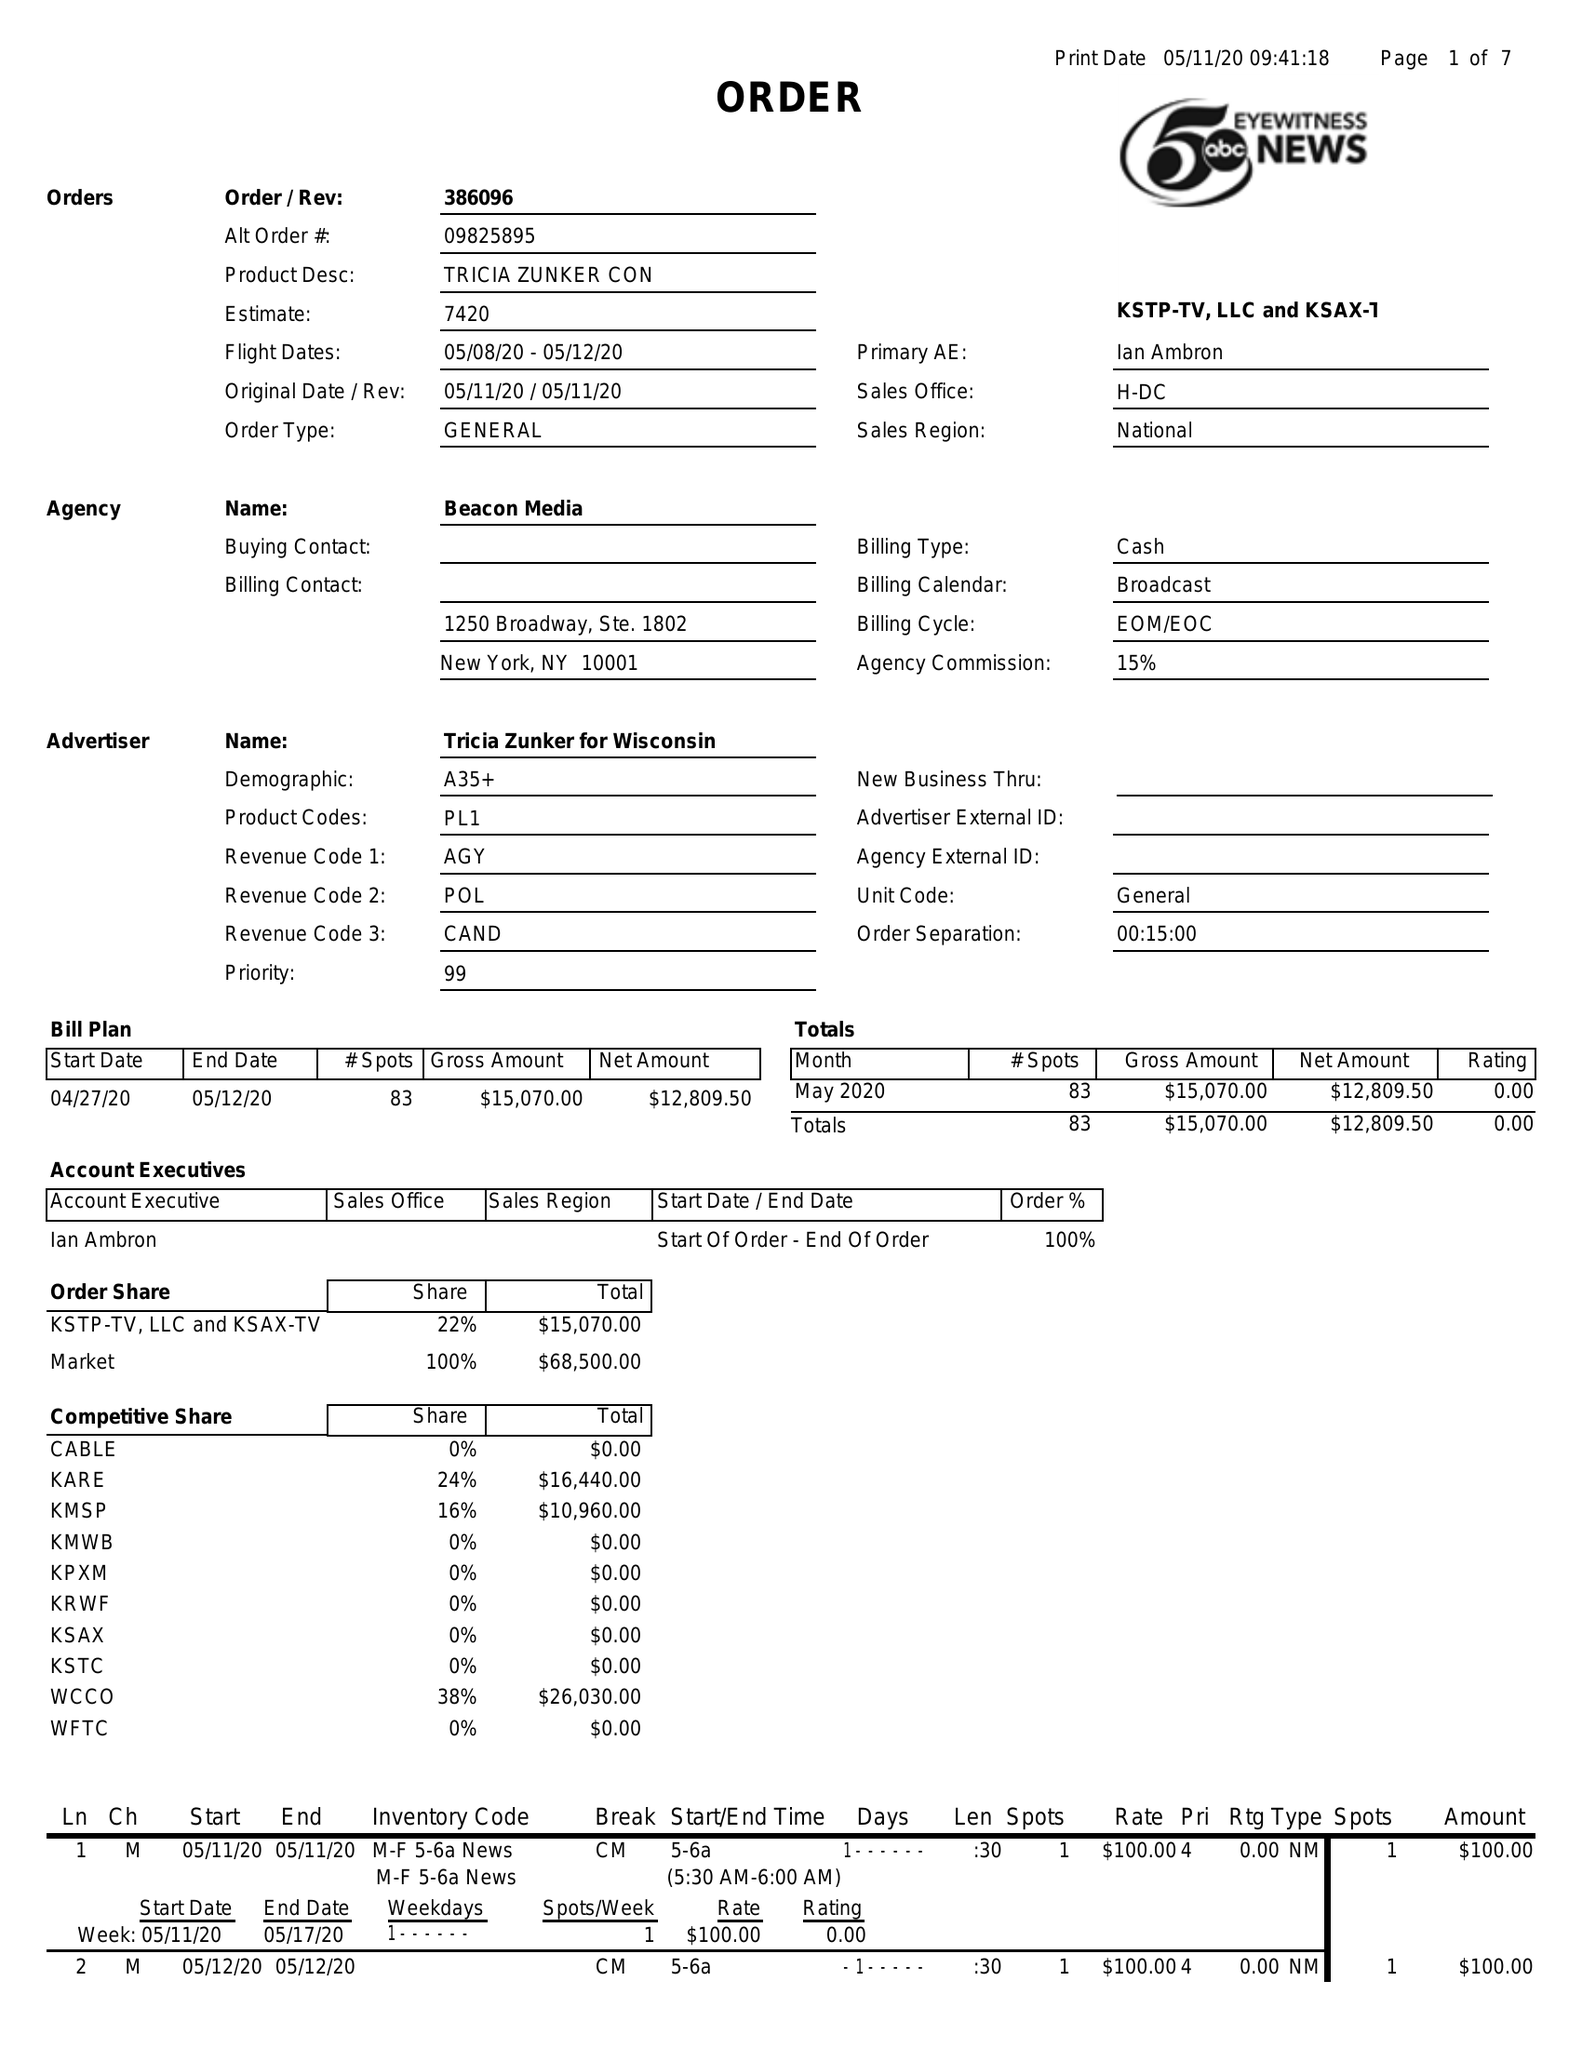What is the value for the gross_amount?
Answer the question using a single word or phrase. 15070.00 